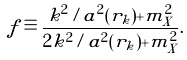Convert formula to latex. <formula><loc_0><loc_0><loc_500><loc_500>f \equiv \frac { k ^ { 2 } / a ^ { 2 } ( r _ { k } ) + m _ { X } ^ { 2 } } { 2 k ^ { 2 } / a ^ { 2 } ( r _ { k } ) + m _ { X } ^ { 2 } } .</formula> 